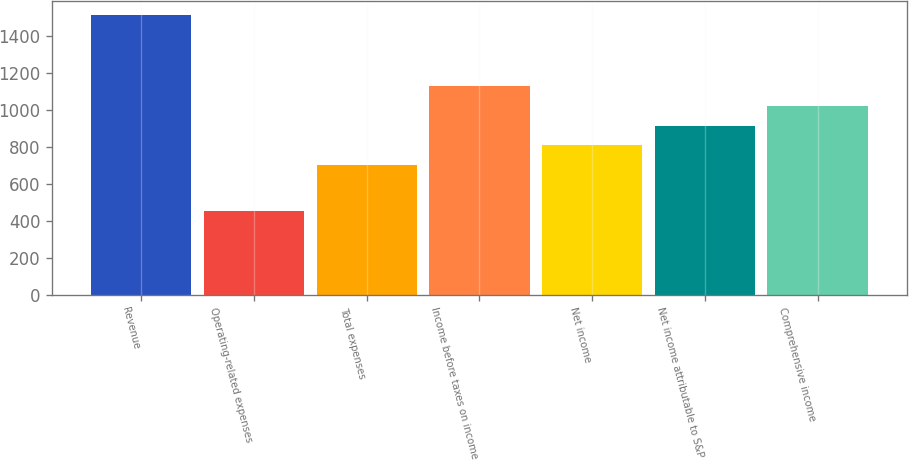Convert chart. <chart><loc_0><loc_0><loc_500><loc_500><bar_chart><fcel>Revenue<fcel>Operating-related expenses<fcel>Total expenses<fcel>Income before taxes on income<fcel>Net income<fcel>Net income attributable to S&P<fcel>Comprehensive income<nl><fcel>1513<fcel>451<fcel>703<fcel>1127.8<fcel>809.2<fcel>915.4<fcel>1021.6<nl></chart> 